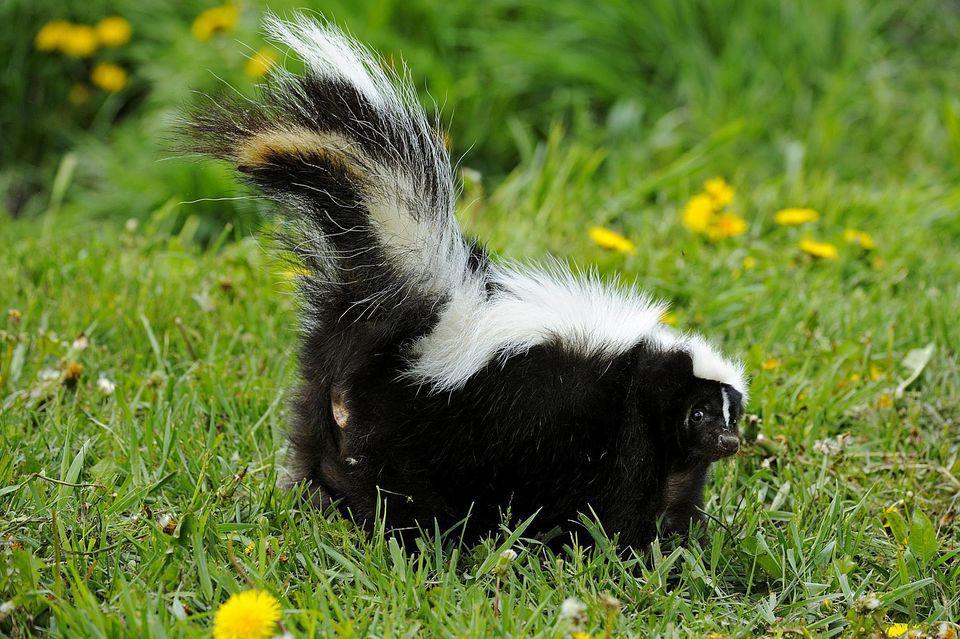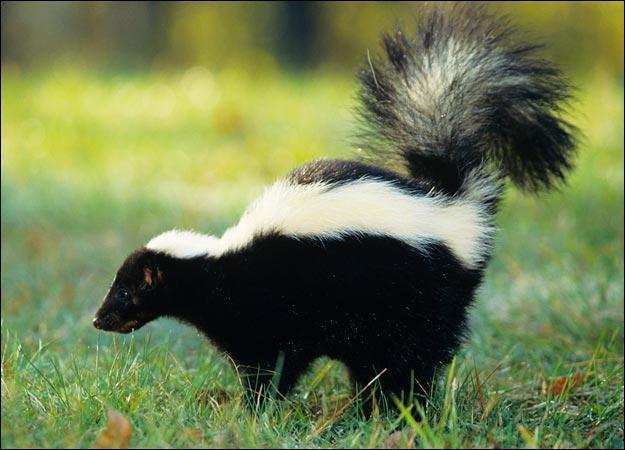The first image is the image on the left, the second image is the image on the right. Considering the images on both sides, is "A skunk is facing to the right in one image and a skunk is facing to the left in another image." valid? Answer yes or no. Yes. 